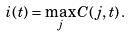<formula> <loc_0><loc_0><loc_500><loc_500>i ( t ) = \max _ { j } C ( j , t ) \, .</formula> 